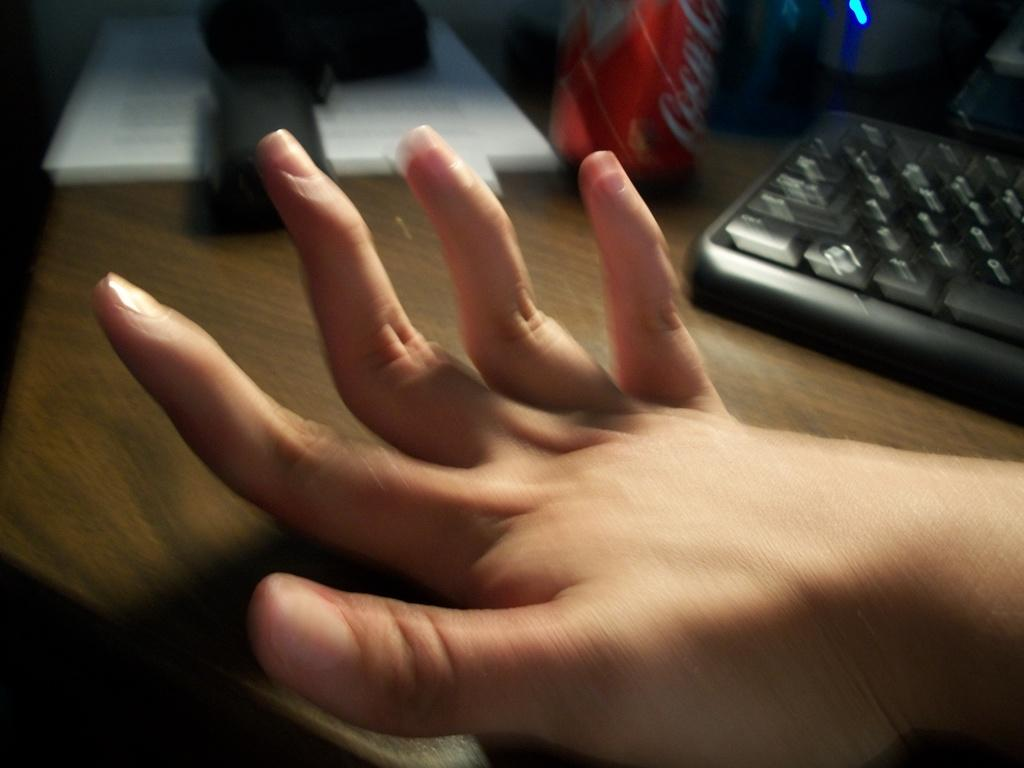What body part is visible in the image? There is a person's hand in the image. What device is the person using, as indicated by the hand? A keyboard is visible in the image. What type of container is present in the image? There is a tin in the image. What surface can be seen in the image, on which objects are placed? There are objects on a wooden surface in the image. What type of pin is being used to hold the person's lip in the image? There is no pin or lip present in the image; only a hand, keyboard, tin, and objects on a wooden surface are visible. 